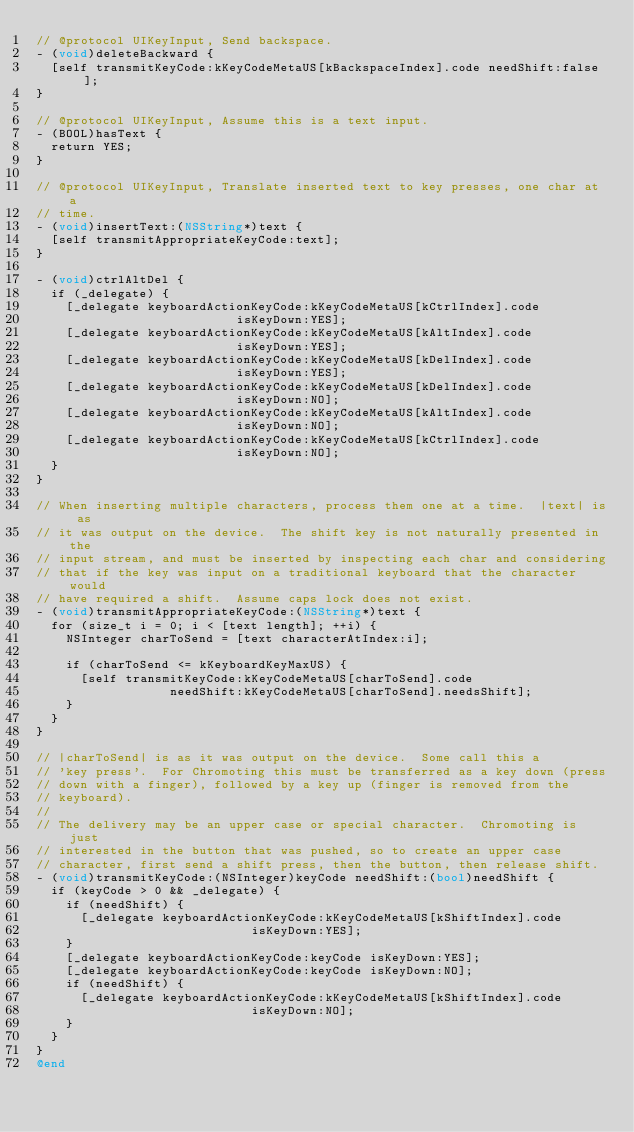Convert code to text. <code><loc_0><loc_0><loc_500><loc_500><_ObjectiveC_>// @protocol UIKeyInput, Send backspace.
- (void)deleteBackward {
  [self transmitKeyCode:kKeyCodeMetaUS[kBackspaceIndex].code needShift:false];
}

// @protocol UIKeyInput, Assume this is a text input.
- (BOOL)hasText {
  return YES;
}

// @protocol UIKeyInput, Translate inserted text to key presses, one char at a
// time.
- (void)insertText:(NSString*)text {
  [self transmitAppropriateKeyCode:text];
}

- (void)ctrlAltDel {
  if (_delegate) {
    [_delegate keyboardActionKeyCode:kKeyCodeMetaUS[kCtrlIndex].code
                           isKeyDown:YES];
    [_delegate keyboardActionKeyCode:kKeyCodeMetaUS[kAltIndex].code
                           isKeyDown:YES];
    [_delegate keyboardActionKeyCode:kKeyCodeMetaUS[kDelIndex].code
                           isKeyDown:YES];
    [_delegate keyboardActionKeyCode:kKeyCodeMetaUS[kDelIndex].code
                           isKeyDown:NO];
    [_delegate keyboardActionKeyCode:kKeyCodeMetaUS[kAltIndex].code
                           isKeyDown:NO];
    [_delegate keyboardActionKeyCode:kKeyCodeMetaUS[kCtrlIndex].code
                           isKeyDown:NO];
  }
}

// When inserting multiple characters, process them one at a time.  |text| is as
// it was output on the device.  The shift key is not naturally presented in the
// input stream, and must be inserted by inspecting each char and considering
// that if the key was input on a traditional keyboard that the character would
// have required a shift.  Assume caps lock does not exist.
- (void)transmitAppropriateKeyCode:(NSString*)text {
  for (size_t i = 0; i < [text length]; ++i) {
    NSInteger charToSend = [text characterAtIndex:i];

    if (charToSend <= kKeyboardKeyMaxUS) {
      [self transmitKeyCode:kKeyCodeMetaUS[charToSend].code
                  needShift:kKeyCodeMetaUS[charToSend].needsShift];
    }
  }
}

// |charToSend| is as it was output on the device.  Some call this a
// 'key press'.  For Chromoting this must be transferred as a key down (press
// down with a finger), followed by a key up (finger is removed from the
// keyboard).
//
// The delivery may be an upper case or special character.  Chromoting is just
// interested in the button that was pushed, so to create an upper case
// character, first send a shift press, then the button, then release shift.
- (void)transmitKeyCode:(NSInteger)keyCode needShift:(bool)needShift {
  if (keyCode > 0 && _delegate) {
    if (needShift) {
      [_delegate keyboardActionKeyCode:kKeyCodeMetaUS[kShiftIndex].code
                             isKeyDown:YES];
    }
    [_delegate keyboardActionKeyCode:keyCode isKeyDown:YES];
    [_delegate keyboardActionKeyCode:keyCode isKeyDown:NO];
    if (needShift) {
      [_delegate keyboardActionKeyCode:kKeyCodeMetaUS[kShiftIndex].code
                             isKeyDown:NO];
    }
  }
}
@end
</code> 